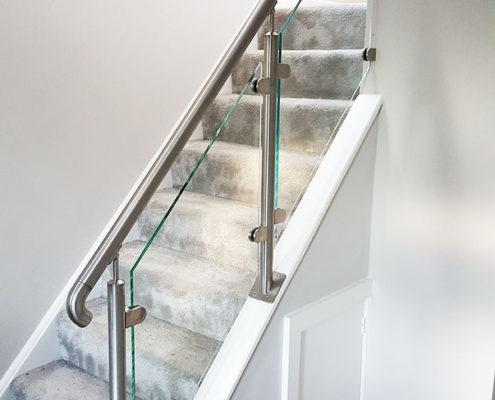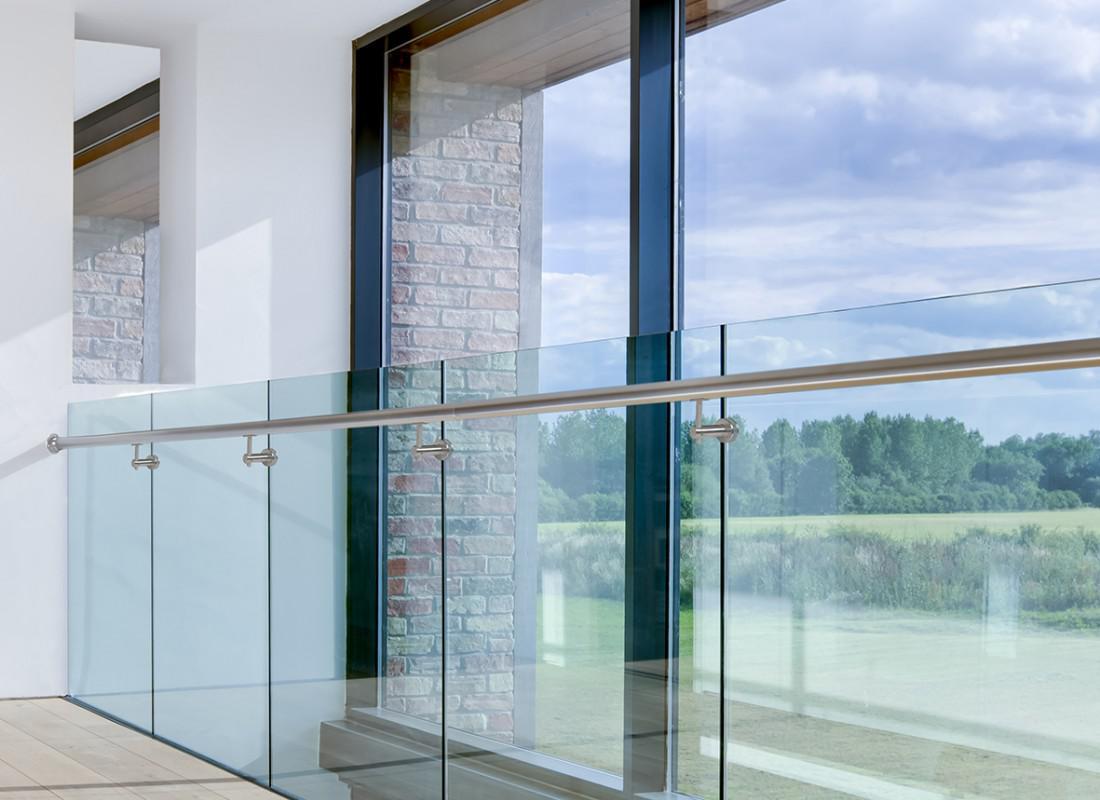The first image is the image on the left, the second image is the image on the right. Assess this claim about the two images: "One image shows a glass-paneled balcony in a white building, and the other shows a glass-paneled staircase railing next to brown wood steps.". Correct or not? Answer yes or no. No. The first image is the image on the left, the second image is the image on the right. Examine the images to the left and right. Is the description "In one image the sky and clouds are visible." accurate? Answer yes or no. Yes. 